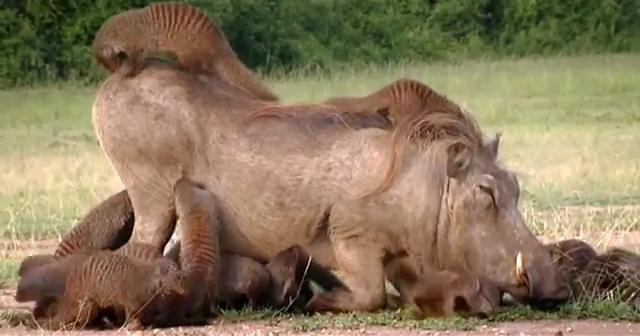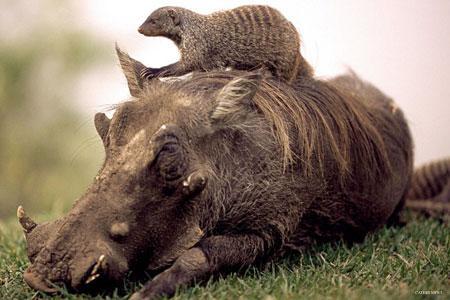The first image is the image on the left, the second image is the image on the right. Evaluate the accuracy of this statement regarding the images: "the right pic has three or less animals". Is it true? Answer yes or no. Yes. 